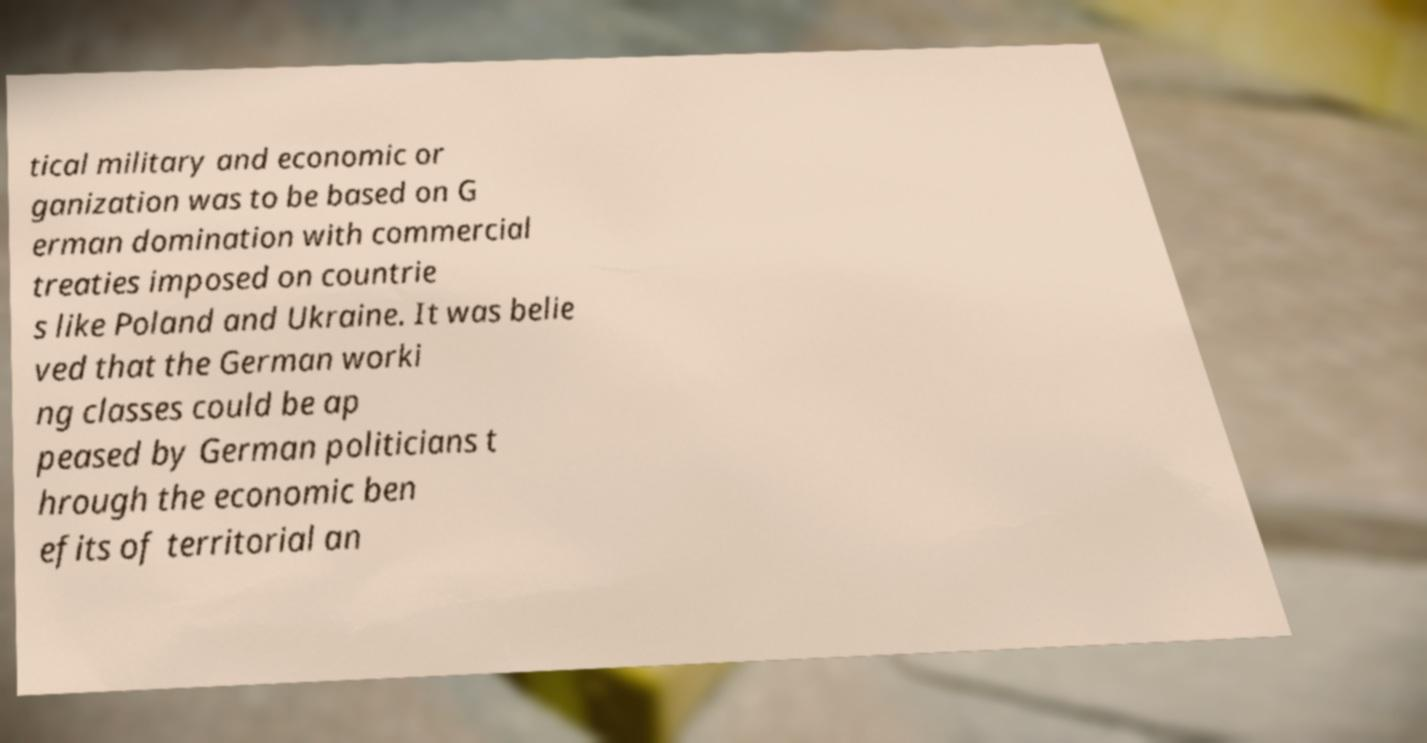Could you extract and type out the text from this image? tical military and economic or ganization was to be based on G erman domination with commercial treaties imposed on countrie s like Poland and Ukraine. It was belie ved that the German worki ng classes could be ap peased by German politicians t hrough the economic ben efits of territorial an 